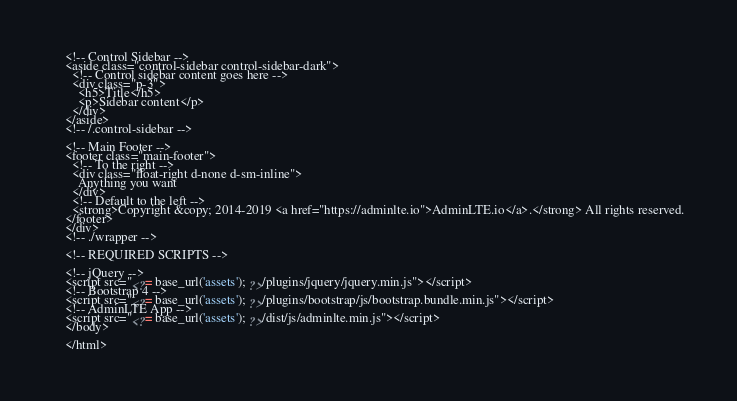Convert code to text. <code><loc_0><loc_0><loc_500><loc_500><_PHP_>    <!-- Control Sidebar -->
    <aside class="control-sidebar control-sidebar-dark">
      <!-- Control sidebar content goes here -->
      <div class="p-3">
        <h5>Title</h5>
        <p>Sidebar content</p>
      </div>
    </aside>
    <!-- /.control-sidebar -->

    <!-- Main Footer -->
    <footer class="main-footer">
      <!-- To the right -->
      <div class="float-right d-none d-sm-inline">
        Anything you want
      </div>
      <!-- Default to the left -->
      <strong>Copyright &copy; 2014-2019 <a href="https://adminlte.io">AdminLTE.io</a>.</strong> All rights reserved.
    </footer>
    </div>
    <!-- ./wrapper -->

    <!-- REQUIRED SCRIPTS -->

    <!-- jQuery -->
    <script src="<?= base_url('assets'); ?>/plugins/jquery/jquery.min.js"></script>
    <!-- Bootstrap 4 -->
    <script src="<?= base_url('assets'); ?>/plugins/bootstrap/js/bootstrap.bundle.min.js"></script>
    <!-- AdminLTE App -->
    <script src="<?= base_url('assets'); ?>/dist/js/adminlte.min.js"></script>
    </body>

    </html></code> 